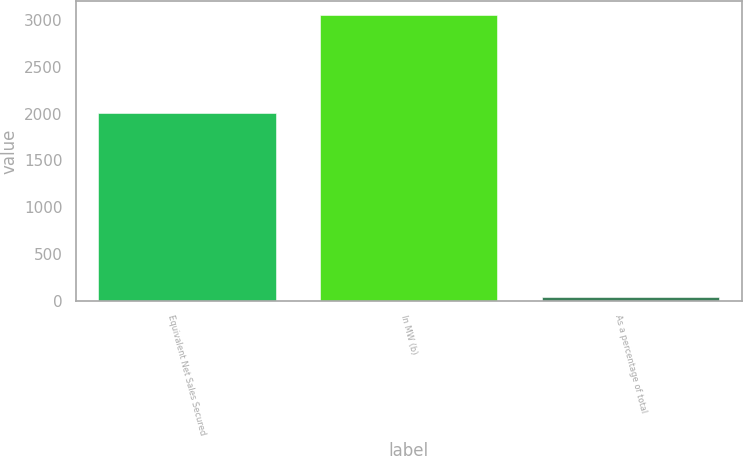<chart> <loc_0><loc_0><loc_500><loc_500><bar_chart><fcel>Equivalent Net Sales Secured<fcel>In MW (b)<fcel>As a percentage of total<nl><fcel>2010<fcel>3050<fcel>45<nl></chart> 